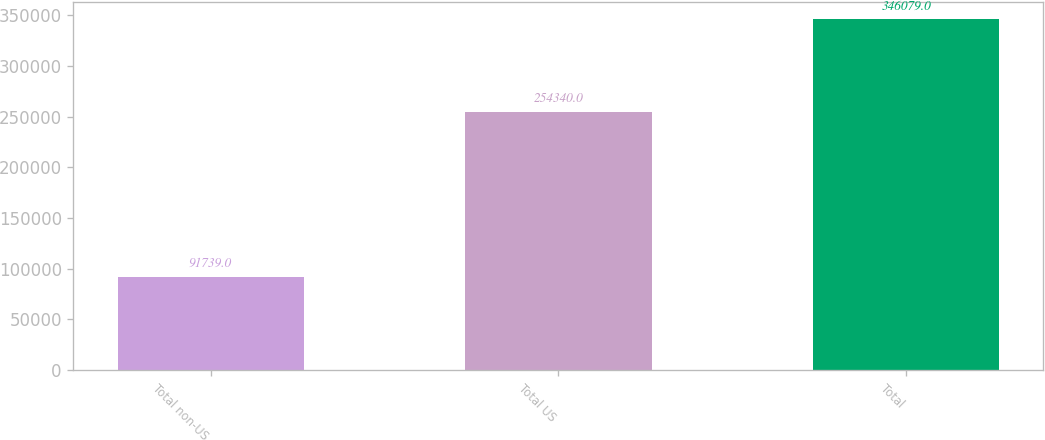Convert chart. <chart><loc_0><loc_0><loc_500><loc_500><bar_chart><fcel>Total non-US<fcel>Total US<fcel>Total<nl><fcel>91739<fcel>254340<fcel>346079<nl></chart> 